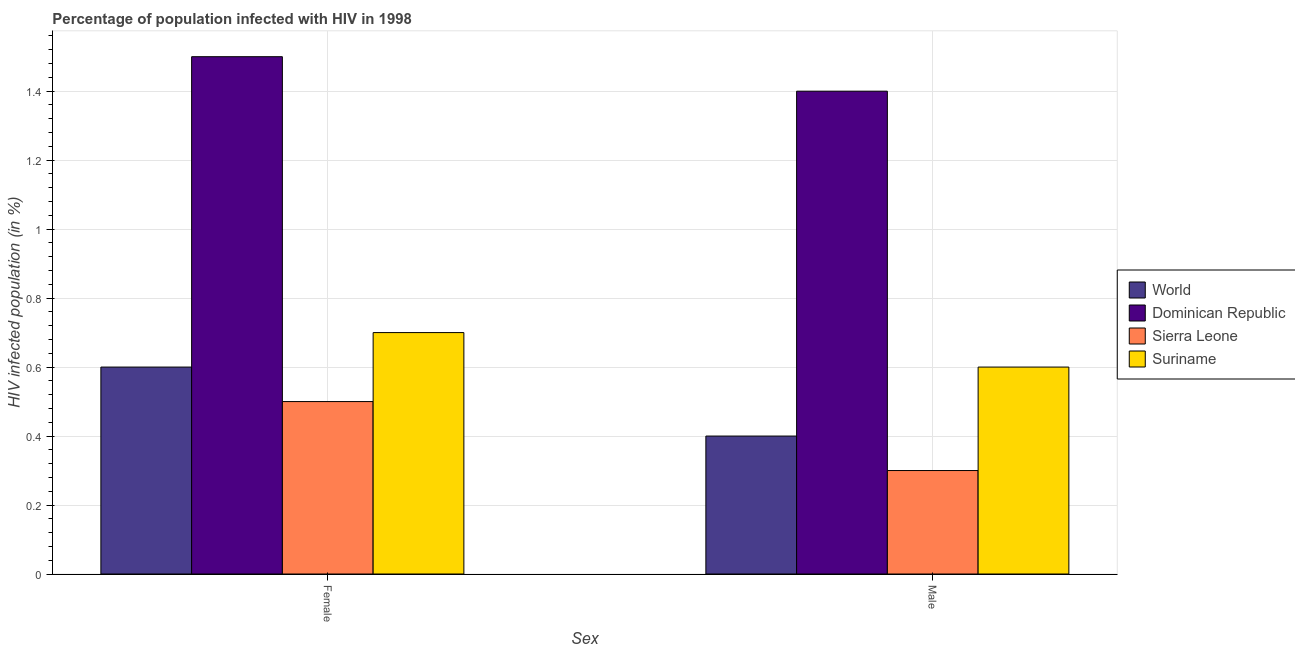How many different coloured bars are there?
Offer a terse response. 4. How many bars are there on the 1st tick from the left?
Keep it short and to the point. 4. How many bars are there on the 1st tick from the right?
Make the answer very short. 4. What is the label of the 1st group of bars from the left?
Your answer should be very brief. Female. Across all countries, what is the maximum percentage of males who are infected with hiv?
Your answer should be compact. 1.4. In which country was the percentage of females who are infected with hiv maximum?
Your answer should be compact. Dominican Republic. In which country was the percentage of males who are infected with hiv minimum?
Offer a very short reply. Sierra Leone. What is the difference between the percentage of males who are infected with hiv in World and the percentage of females who are infected with hiv in Suriname?
Offer a very short reply. -0.3. What is the average percentage of females who are infected with hiv per country?
Provide a succinct answer. 0.82. What is the difference between the percentage of males who are infected with hiv and percentage of females who are infected with hiv in World?
Your response must be concise. -0.2. In how many countries, is the percentage of females who are infected with hiv greater than 0.12 %?
Your response must be concise. 4. What is the ratio of the percentage of males who are infected with hiv in Dominican Republic to that in Sierra Leone?
Keep it short and to the point. 4.67. Is the percentage of males who are infected with hiv in World less than that in Sierra Leone?
Ensure brevity in your answer.  No. In how many countries, is the percentage of males who are infected with hiv greater than the average percentage of males who are infected with hiv taken over all countries?
Offer a very short reply. 1. What does the 4th bar from the left in Male represents?
Your answer should be compact. Suriname. What does the 2nd bar from the right in Male represents?
Your response must be concise. Sierra Leone. How many bars are there?
Ensure brevity in your answer.  8. Are all the bars in the graph horizontal?
Offer a terse response. No. Does the graph contain any zero values?
Offer a terse response. No. Where does the legend appear in the graph?
Offer a very short reply. Center right. How are the legend labels stacked?
Provide a short and direct response. Vertical. What is the title of the graph?
Provide a short and direct response. Percentage of population infected with HIV in 1998. What is the label or title of the X-axis?
Ensure brevity in your answer.  Sex. What is the label or title of the Y-axis?
Your answer should be very brief. HIV infected population (in %). What is the HIV infected population (in %) in World in Female?
Provide a succinct answer. 0.6. What is the HIV infected population (in %) in Suriname in Female?
Your answer should be compact. 0.7. What is the HIV infected population (in %) of Dominican Republic in Male?
Give a very brief answer. 1.4. What is the HIV infected population (in %) in Suriname in Male?
Provide a succinct answer. 0.6. Across all Sex, what is the maximum HIV infected population (in %) in Dominican Republic?
Keep it short and to the point. 1.5. Across all Sex, what is the maximum HIV infected population (in %) in Sierra Leone?
Provide a succinct answer. 0.5. Across all Sex, what is the maximum HIV infected population (in %) of Suriname?
Keep it short and to the point. 0.7. Across all Sex, what is the minimum HIV infected population (in %) of World?
Provide a short and direct response. 0.4. What is the total HIV infected population (in %) in World in the graph?
Offer a very short reply. 1. What is the total HIV infected population (in %) of Dominican Republic in the graph?
Provide a short and direct response. 2.9. What is the difference between the HIV infected population (in %) of World in Female and that in Male?
Provide a short and direct response. 0.2. What is the difference between the HIV infected population (in %) in Dominican Republic in Female and that in Male?
Provide a short and direct response. 0.1. What is the difference between the HIV infected population (in %) of Suriname in Female and that in Male?
Your response must be concise. 0.1. What is the difference between the HIV infected population (in %) of World in Female and the HIV infected population (in %) of Sierra Leone in Male?
Your response must be concise. 0.3. What is the difference between the HIV infected population (in %) of World in Female and the HIV infected population (in %) of Suriname in Male?
Keep it short and to the point. 0. What is the average HIV infected population (in %) in World per Sex?
Give a very brief answer. 0.5. What is the average HIV infected population (in %) of Dominican Republic per Sex?
Provide a succinct answer. 1.45. What is the average HIV infected population (in %) in Sierra Leone per Sex?
Your answer should be very brief. 0.4. What is the average HIV infected population (in %) in Suriname per Sex?
Give a very brief answer. 0.65. What is the difference between the HIV infected population (in %) of World and HIV infected population (in %) of Dominican Republic in Female?
Keep it short and to the point. -0.9. What is the difference between the HIV infected population (in %) in World and HIV infected population (in %) in Suriname in Female?
Ensure brevity in your answer.  -0.1. What is the difference between the HIV infected population (in %) in Dominican Republic and HIV infected population (in %) in Sierra Leone in Female?
Offer a very short reply. 1. What is the difference between the HIV infected population (in %) of Dominican Republic and HIV infected population (in %) of Suriname in Female?
Your answer should be compact. 0.8. What is the difference between the HIV infected population (in %) in Sierra Leone and HIV infected population (in %) in Suriname in Female?
Your response must be concise. -0.2. What is the difference between the HIV infected population (in %) in Dominican Republic and HIV infected population (in %) in Sierra Leone in Male?
Provide a succinct answer. 1.1. What is the difference between the HIV infected population (in %) of Dominican Republic and HIV infected population (in %) of Suriname in Male?
Your response must be concise. 0.8. What is the difference between the HIV infected population (in %) in Sierra Leone and HIV infected population (in %) in Suriname in Male?
Make the answer very short. -0.3. What is the ratio of the HIV infected population (in %) of Dominican Republic in Female to that in Male?
Your response must be concise. 1.07. What is the ratio of the HIV infected population (in %) in Suriname in Female to that in Male?
Provide a succinct answer. 1.17. What is the difference between the highest and the second highest HIV infected population (in %) in Dominican Republic?
Your answer should be compact. 0.1. What is the difference between the highest and the second highest HIV infected population (in %) of Suriname?
Your answer should be compact. 0.1. What is the difference between the highest and the lowest HIV infected population (in %) in Sierra Leone?
Give a very brief answer. 0.2. What is the difference between the highest and the lowest HIV infected population (in %) in Suriname?
Provide a short and direct response. 0.1. 